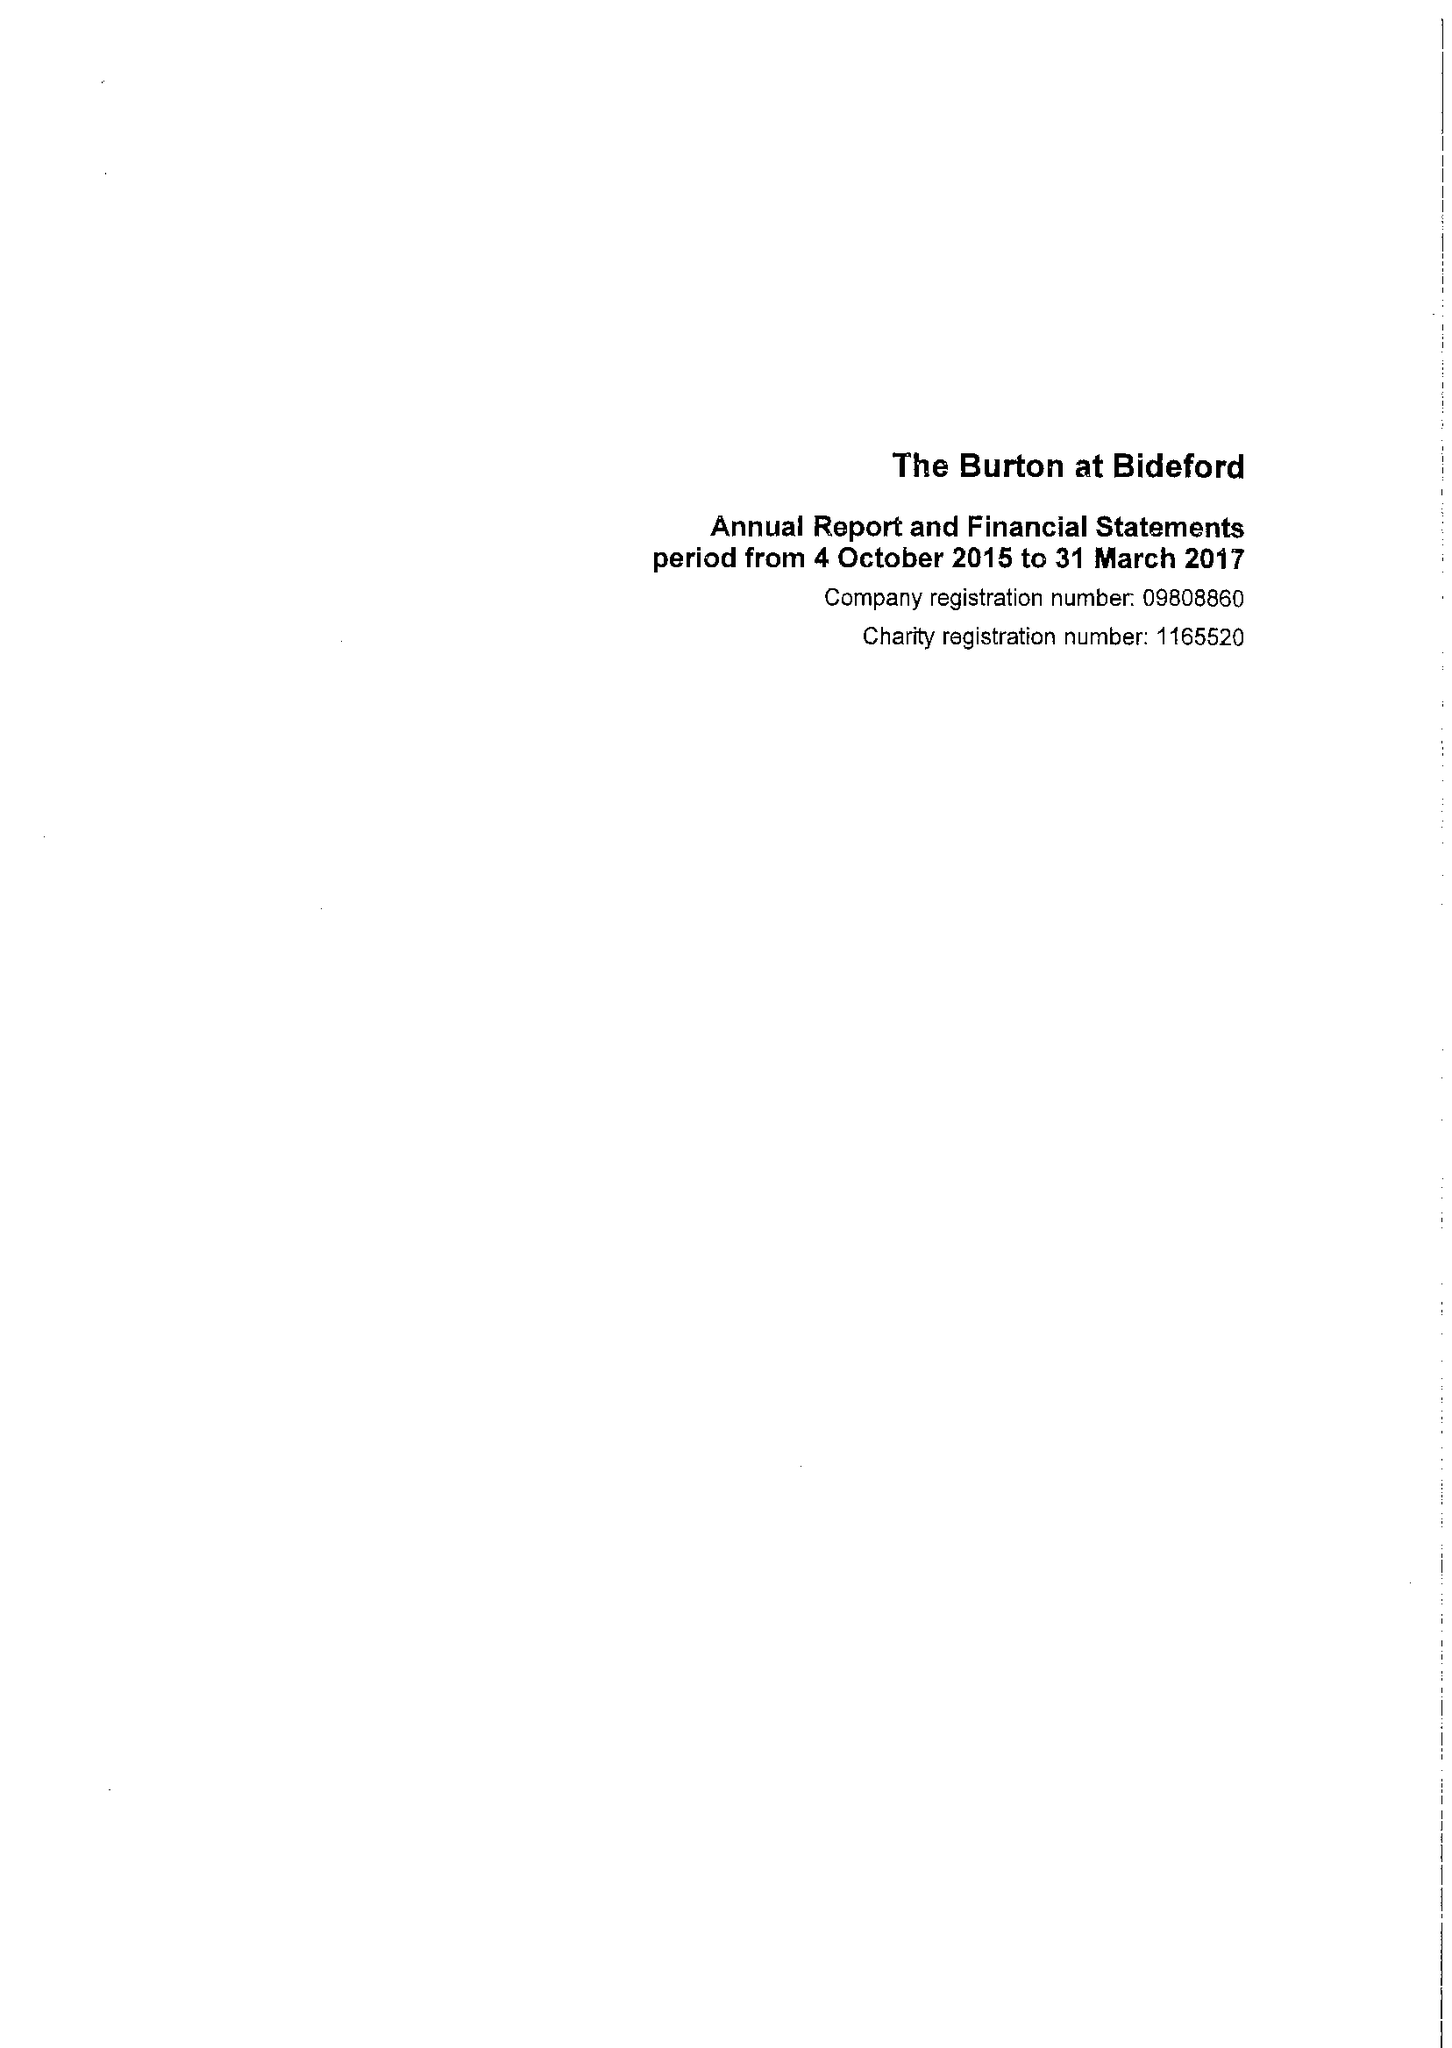What is the value for the address__post_town?
Answer the question using a single word or phrase. BIDEFORD 